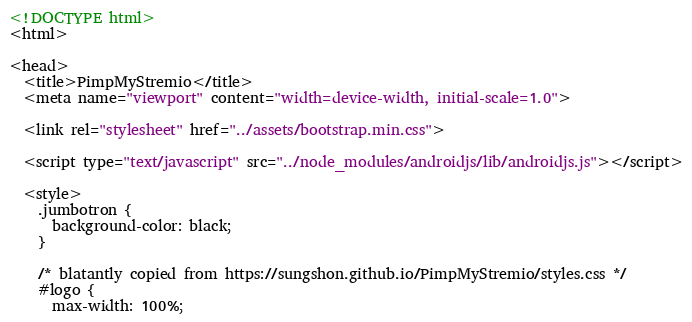Convert code to text. <code><loc_0><loc_0><loc_500><loc_500><_HTML_><!DOCTYPE html>
<html>

<head>
  <title>PimpMyStremio</title>
  <meta name="viewport" content="width=device-width, initial-scale=1.0">

  <link rel="stylesheet" href="../assets/bootstrap.min.css">

  <script type="text/javascript" src="../node_modules/androidjs/lib/androidjs.js"></script>

  <style>
    .jumbotron {
      background-color: black;
    }

    /* blatantly copied from https://sungshon.github.io/PimpMyStremio/styles.css */
    #logo {
      max-width: 100%;</code> 